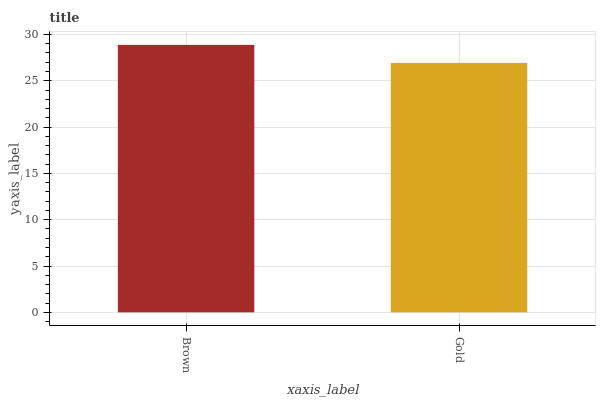Is Gold the minimum?
Answer yes or no. Yes. Is Brown the maximum?
Answer yes or no. Yes. Is Gold the maximum?
Answer yes or no. No. Is Brown greater than Gold?
Answer yes or no. Yes. Is Gold less than Brown?
Answer yes or no. Yes. Is Gold greater than Brown?
Answer yes or no. No. Is Brown less than Gold?
Answer yes or no. No. Is Brown the high median?
Answer yes or no. Yes. Is Gold the low median?
Answer yes or no. Yes. Is Gold the high median?
Answer yes or no. No. Is Brown the low median?
Answer yes or no. No. 